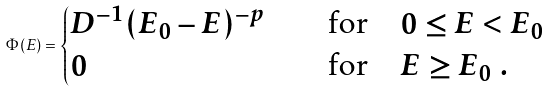<formula> <loc_0><loc_0><loc_500><loc_500>\Phi ( E ) = \begin{cases} D ^ { - 1 } ( E _ { 0 } - E ) ^ { - p } \quad & \text {for} \quad 0 \leq E < E _ { 0 } \\ 0 \quad & \text {for} \quad E \geq E _ { 0 } \ . \end{cases}</formula> 